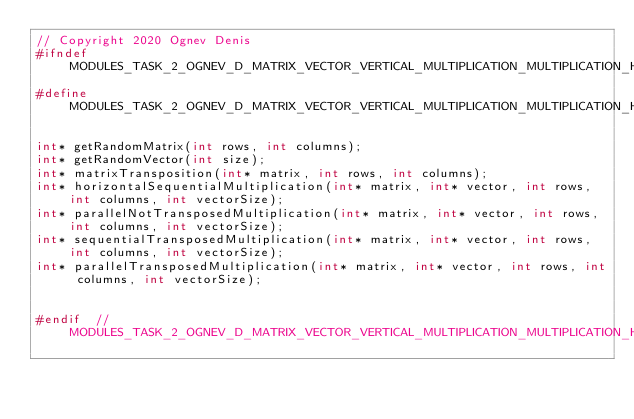<code> <loc_0><loc_0><loc_500><loc_500><_C_>// Copyright 2020 Ognev Denis
#ifndef MODULES_TASK_2_OGNEV_D_MATRIX_VECTOR_VERTICAL_MULTIPLICATION_MULTIPLICATION_H_
#define MODULES_TASK_2_OGNEV_D_MATRIX_VECTOR_VERTICAL_MULTIPLICATION_MULTIPLICATION_H_

int* getRandomMatrix(int rows, int columns);
int* getRandomVector(int size);
int* matrixTransposition(int* matrix, int rows, int columns);
int* horizontalSequentialMultiplication(int* matrix, int* vector, int rows, int columns, int vectorSize);
int* parallelNotTransposedMultiplication(int* matrix, int* vector, int rows, int columns, int vectorSize);
int* sequentialTransposedMultiplication(int* matrix, int* vector, int rows, int columns, int vectorSize);
int* parallelTransposedMultiplication(int* matrix, int* vector, int rows, int columns, int vectorSize);


#endif  // MODULES_TASK_2_OGNEV_D_MATRIX_VECTOR_VERTICAL_MULTIPLICATION_MULTIPLICATION_H_
</code> 